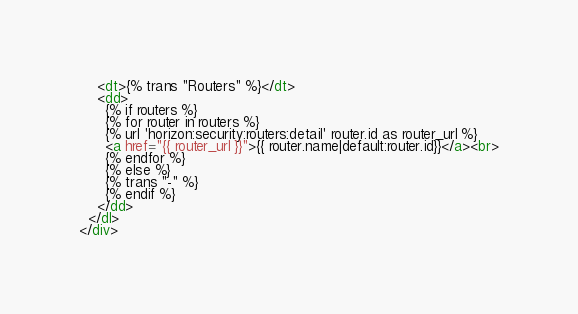<code> <loc_0><loc_0><loc_500><loc_500><_HTML_>
    <dt>{% trans "Routers" %}</dt>
    <dd>
      {% if routers %}
      {% for router in routers %}
      {% url 'horizon:security:routers:detail' router.id as router_url %}
      <a href="{{ router_url }}">{{ router.name|default:router.id}}</a><br>
      {% endfor %}
      {% else %}
      {% trans "-" %}
      {% endif %}
    </dd>
  </dl>
</div>
</code> 